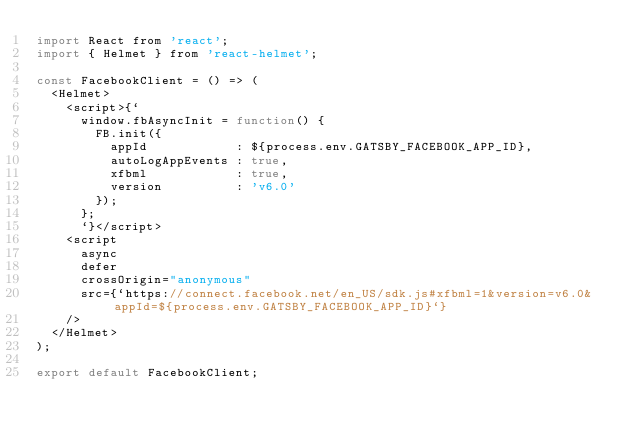<code> <loc_0><loc_0><loc_500><loc_500><_JavaScript_>import React from 'react';
import { Helmet } from 'react-helmet';

const FacebookClient = () => (
  <Helmet>
    <script>{`
      window.fbAsyncInit = function() {
        FB.init({
          appId            : ${process.env.GATSBY_FACEBOOK_APP_ID},
          autoLogAppEvents : true,
          xfbml            : true,
          version          : 'v6.0'
        });
      };
      `}</script>
    <script
      async
      defer
      crossOrigin="anonymous"
      src={`https://connect.facebook.net/en_US/sdk.js#xfbml=1&version=v6.0&appId=${process.env.GATSBY_FACEBOOK_APP_ID}`}
    />
  </Helmet>
);

export default FacebookClient;
</code> 